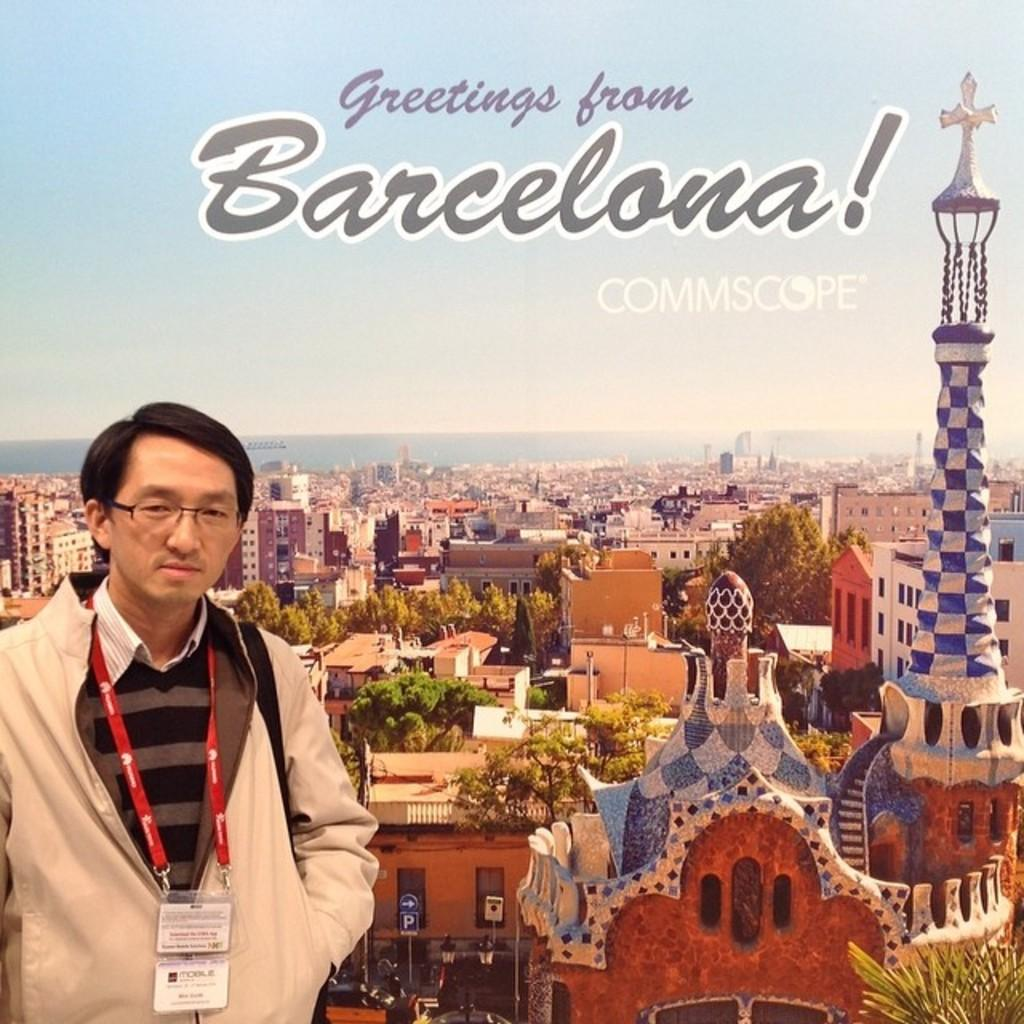What type of visual material is depicted in the image? The image is a poster. Can you describe the person on the left side of the poster? There is a person on the left side of the poster. What can be seen in the background of the poster? There are trees, buildings, and the sky visible in the background of the poster. Is there any text on the poster? Yes, there is some text on the top of the poster. How does the goose attack the person on the poster? There is no goose present in the image, and therefore no such attack can be observed. 